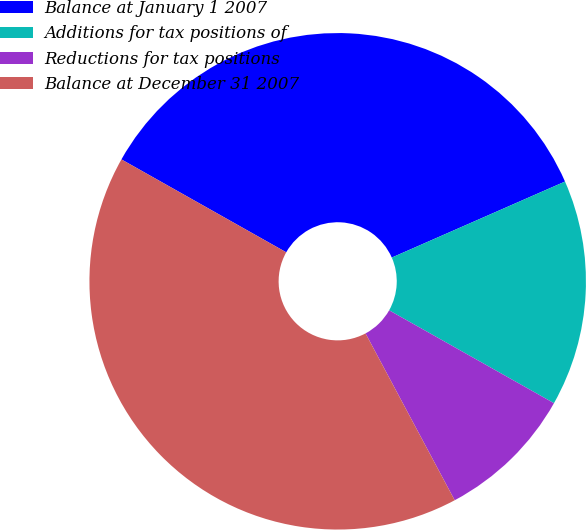Convert chart to OTSL. <chart><loc_0><loc_0><loc_500><loc_500><pie_chart><fcel>Balance at January 1 2007<fcel>Additions for tax positions of<fcel>Reductions for tax positions<fcel>Balance at December 31 2007<nl><fcel>35.25%<fcel>14.75%<fcel>9.02%<fcel>40.98%<nl></chart> 